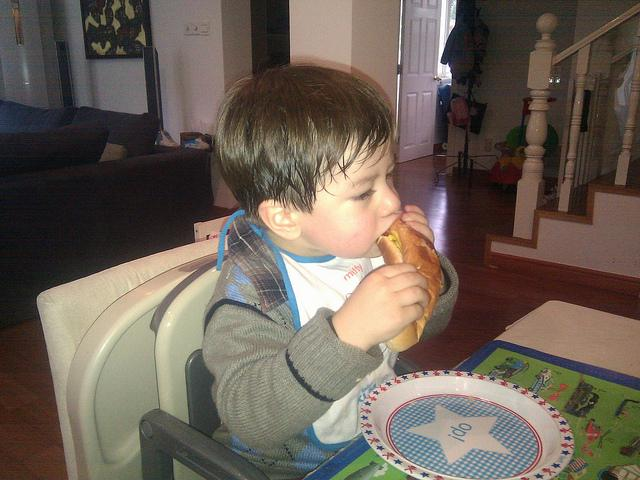What color is the plaid pattern around the star on top of the plate? blue 